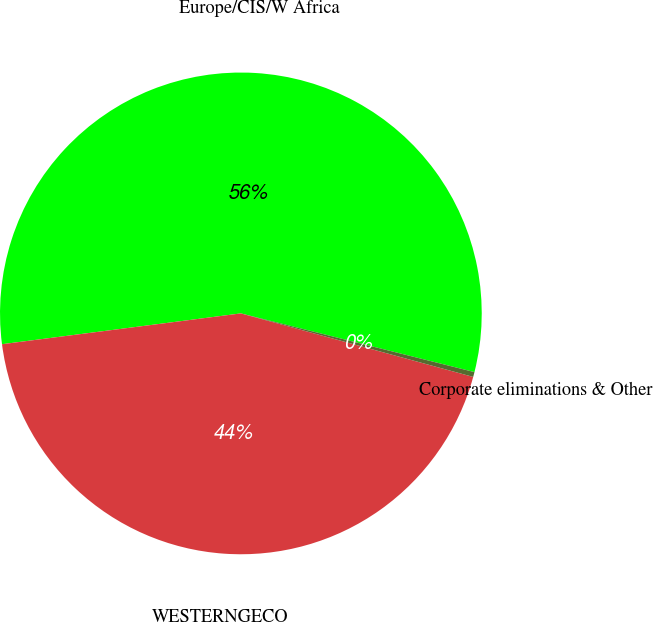<chart> <loc_0><loc_0><loc_500><loc_500><pie_chart><fcel>Europe/CIS/W Africa<fcel>WESTERNGECO<fcel>Corporate eliminations & Other<nl><fcel>55.96%<fcel>43.71%<fcel>0.33%<nl></chart> 